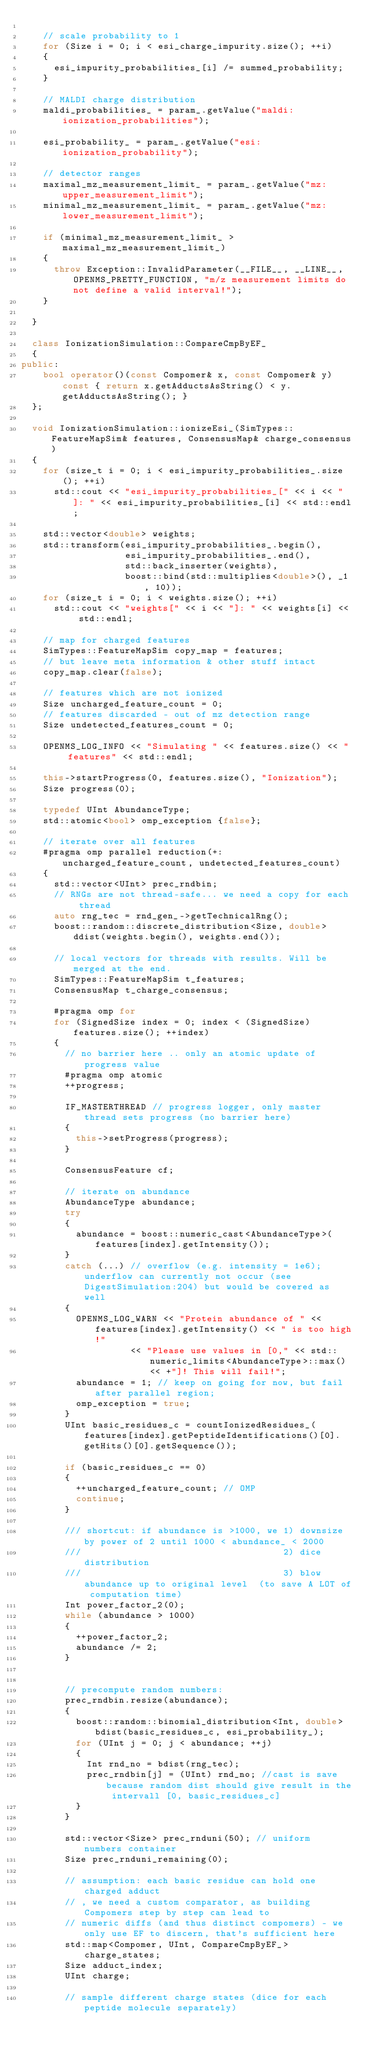Convert code to text. <code><loc_0><loc_0><loc_500><loc_500><_C++_>
    // scale probability to 1
    for (Size i = 0; i < esi_charge_impurity.size(); ++i)
    {
      esi_impurity_probabilities_[i] /= summed_probability;
    }

    // MALDI charge distribution
    maldi_probabilities_ = param_.getValue("maldi:ionization_probabilities");

    esi_probability_ = param_.getValue("esi:ionization_probability");

    // detector ranges
    maximal_mz_measurement_limit_ = param_.getValue("mz:upper_measurement_limit");
    minimal_mz_measurement_limit_ = param_.getValue("mz:lower_measurement_limit");

    if (minimal_mz_measurement_limit_ > maximal_mz_measurement_limit_)
    {
      throw Exception::InvalidParameter(__FILE__, __LINE__, OPENMS_PRETTY_FUNCTION, "m/z measurement limits do not define a valid interval!");
    }

  }

  class IonizationSimulation::CompareCmpByEF_
  {
public:
    bool operator()(const Compomer& x, const Compomer& y) const { return x.getAdductsAsString() < y.getAdductsAsString(); }
  };

  void IonizationSimulation::ionizeEsi_(SimTypes::FeatureMapSim& features, ConsensusMap& charge_consensus)
  {
    for (size_t i = 0; i < esi_impurity_probabilities_.size(); ++i)
      std::cout << "esi_impurity_probabilities_[" << i << "]: " << esi_impurity_probabilities_[i] << std::endl;

    std::vector<double> weights;
    std::transform(esi_impurity_probabilities_.begin(),
                   esi_impurity_probabilities_.end(),
                   std::back_inserter(weights),
                   boost::bind(std::multiplies<double>(), _1, 10));
    for (size_t i = 0; i < weights.size(); ++i)
      std::cout << "weights[" << i << "]: " << weights[i] << std::endl;

    // map for charged features
    SimTypes::FeatureMapSim copy_map = features;
    // but leave meta information & other stuff intact
    copy_map.clear(false);

    // features which are not ionized
    Size uncharged_feature_count = 0;
    // features discarded - out of mz detection range
    Size undetected_features_count = 0;

    OPENMS_LOG_INFO << "Simulating " << features.size() << " features" << std::endl;

    this->startProgress(0, features.size(), "Ionization");
    Size progress(0);
      
    typedef UInt AbundanceType;
    std::atomic<bool> omp_exception {false};

    // iterate over all features
    #pragma omp parallel reduction(+: uncharged_feature_count, undetected_features_count)
    {
      std::vector<UInt> prec_rndbin;
      // RNGs are not thread-safe... we need a copy for each thread
      auto rng_tec = rnd_gen_->getTechnicalRng();
      boost::random::discrete_distribution<Size, double> ddist(weights.begin(), weights.end());
        
      // local vectors for threads with results. Will be merged at the end.
      SimTypes::FeatureMapSim t_features;
      ConsensusMap t_charge_consensus;

      #pragma omp for
      for (SignedSize index = 0; index < (SignedSize)features.size(); ++index)
      {
        // no barrier here .. only an atomic update of progress value
        #pragma omp atomic
        ++progress;

        IF_MASTERTHREAD // progress logger, only master thread sets progress (no barrier here)
        {
          this->setProgress(progress);
        }

        ConsensusFeature cf;

        // iterate on abundance
        AbundanceType abundance;
        try
        {
          abundance = boost::numeric_cast<AbundanceType>(features[index].getIntensity());
        }
        catch (...) // overflow (e.g. intensity = 1e6); underflow can currently not occur (see DigestSimulation:204) but would be covered as well
        {
          OPENMS_LOG_WARN << "Protein abundance of " << features[index].getIntensity() << " is too high!"
                    << "Please use values in [0," << std::numeric_limits<AbundanceType>::max() << +"]! This will fail!";
          abundance = 1; // keep on going for now, but fail after parallel region;
          omp_exception = true;
        }
        UInt basic_residues_c = countIonizedResidues_(features[index].getPeptideIdentifications()[0].getHits()[0].getSequence());

        if (basic_residues_c == 0)
        {
          ++uncharged_feature_count; // OMP
          continue;
        }

        /// shortcut: if abundance is >1000, we 1) downsize by power of 2 until 1000 < abundance_ < 2000
        ///                                     2) dice distribution
        ///                                     3) blow abundance up to original level  (to save A LOT of computation time)
        Int power_factor_2(0);
        while (abundance > 1000)
        {
          ++power_factor_2;
          abundance /= 2;
        }


        // precompute random numbers:
        prec_rndbin.resize(abundance);
        {
          boost::random::binomial_distribution<Int, double> bdist(basic_residues_c, esi_probability_);
          for (UInt j = 0; j < abundance; ++j)
          {
            Int rnd_no = bdist(rng_tec);
            prec_rndbin[j] = (UInt) rnd_no; //cast is save because random dist should give result in the intervall [0, basic_residues_c]
          }
        }

        std::vector<Size> prec_rnduni(50); // uniform numbers container
        Size prec_rnduni_remaining(0);

        // assumption: each basic residue can hold one charged adduct
        // , we need a custom comparator, as building Compomers step by step can lead to
        // numeric diffs (and thus distinct compomers) - we only use EF to discern, that's sufficient here
        std::map<Compomer, UInt, CompareCmpByEF_> charge_states;
        Size adduct_index;
        UInt charge;

        // sample different charge states (dice for each peptide molecule separately)</code> 